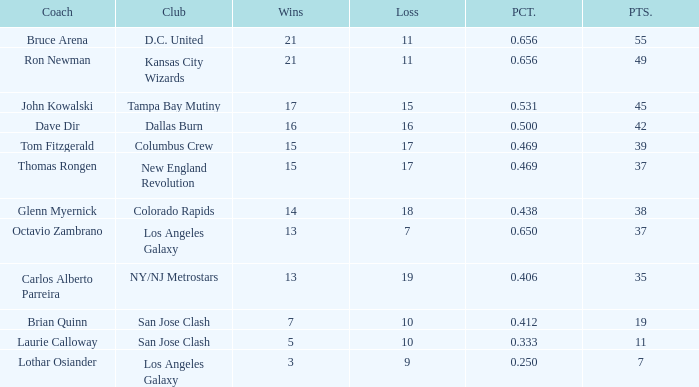What is the sum of points when Bruce Arena has 21 wins? 55.0. 